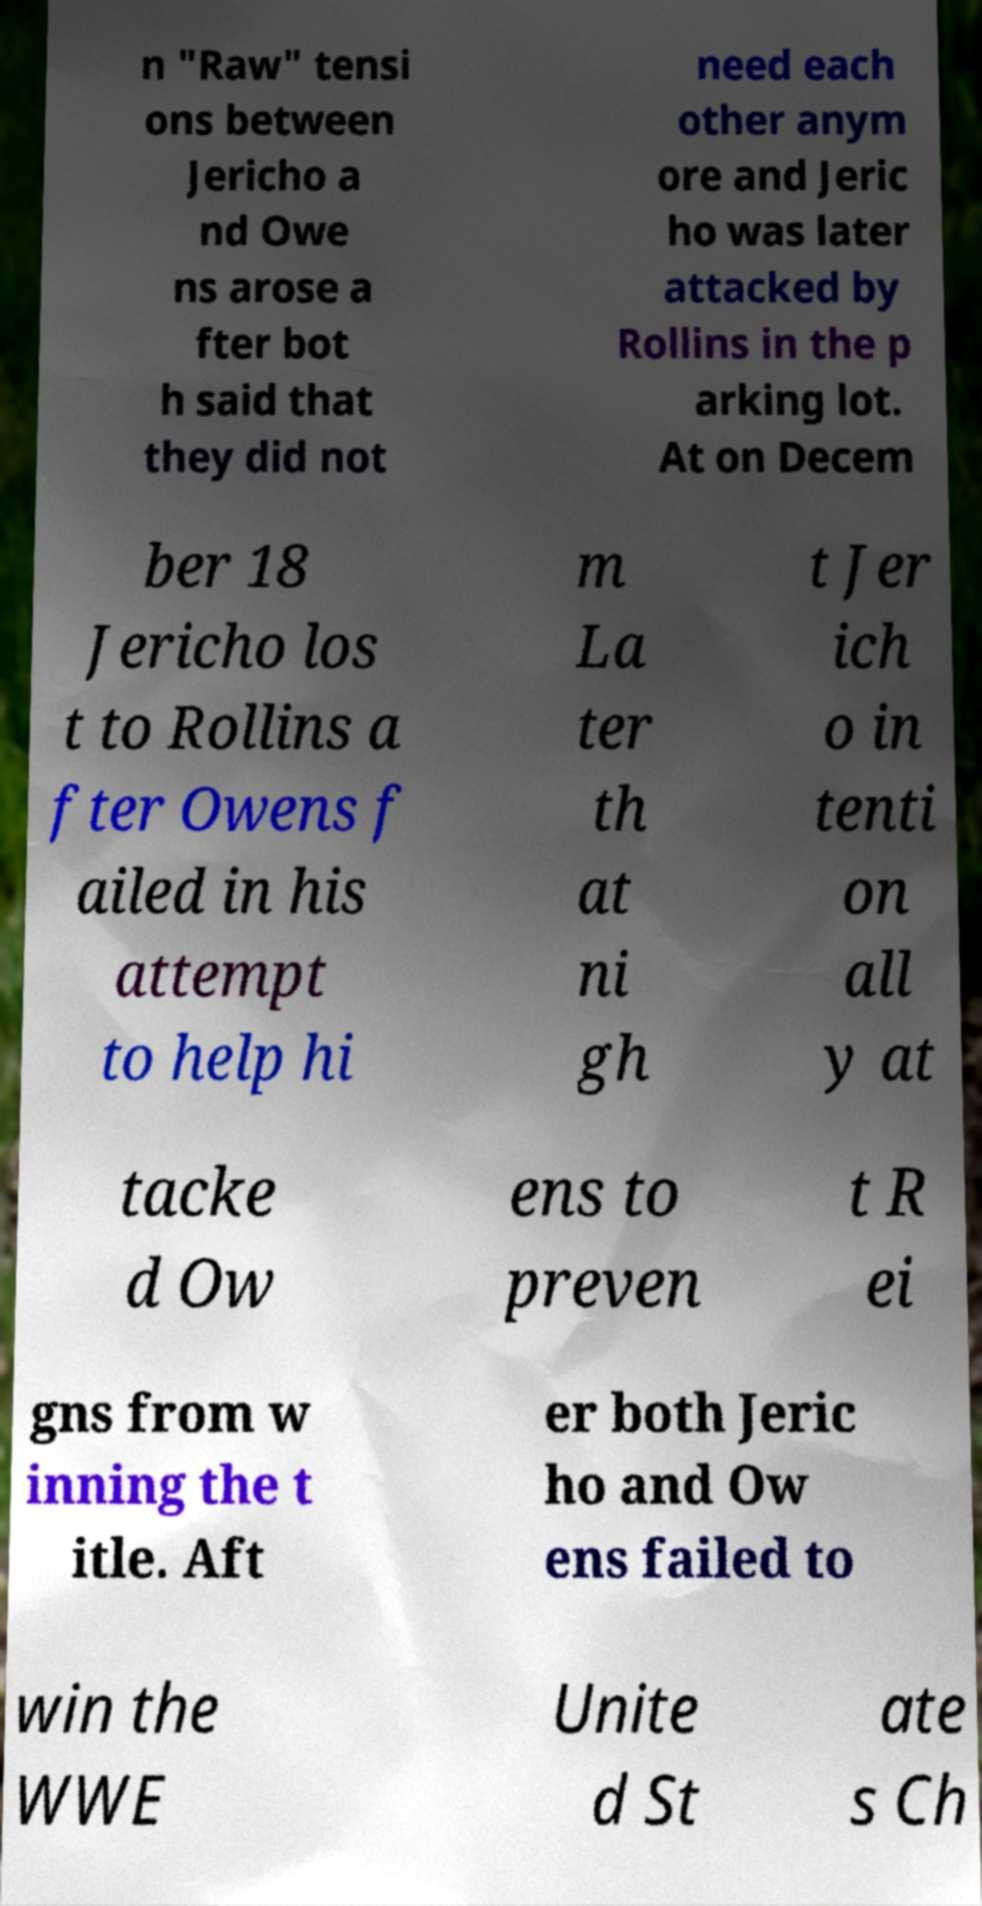Could you assist in decoding the text presented in this image and type it out clearly? n "Raw" tensi ons between Jericho a nd Owe ns arose a fter bot h said that they did not need each other anym ore and Jeric ho was later attacked by Rollins in the p arking lot. At on Decem ber 18 Jericho los t to Rollins a fter Owens f ailed in his attempt to help hi m La ter th at ni gh t Jer ich o in tenti on all y at tacke d Ow ens to preven t R ei gns from w inning the t itle. Aft er both Jeric ho and Ow ens failed to win the WWE Unite d St ate s Ch 